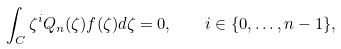Convert formula to latex. <formula><loc_0><loc_0><loc_500><loc_500>\int _ { C } \zeta ^ { i } Q _ { n } ( \zeta ) f ( \zeta ) d \zeta = 0 , \quad i \in \{ 0 , \dots , n - 1 \} ,</formula> 